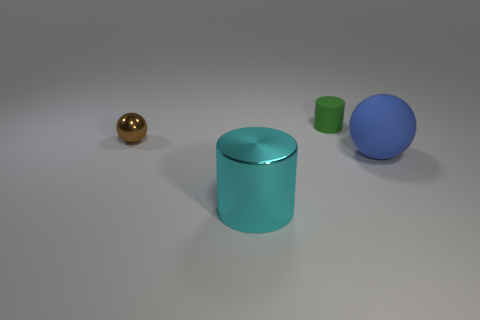Add 1 green things. How many objects exist? 5 Subtract 0 cyan spheres. How many objects are left? 4 Subtract 1 cylinders. How many cylinders are left? 1 Subtract all purple cylinders. Subtract all gray balls. How many cylinders are left? 2 Subtract all metallic balls. Subtract all green things. How many objects are left? 2 Add 4 brown objects. How many brown objects are left? 5 Add 4 tiny brown metal things. How many tiny brown metal things exist? 5 